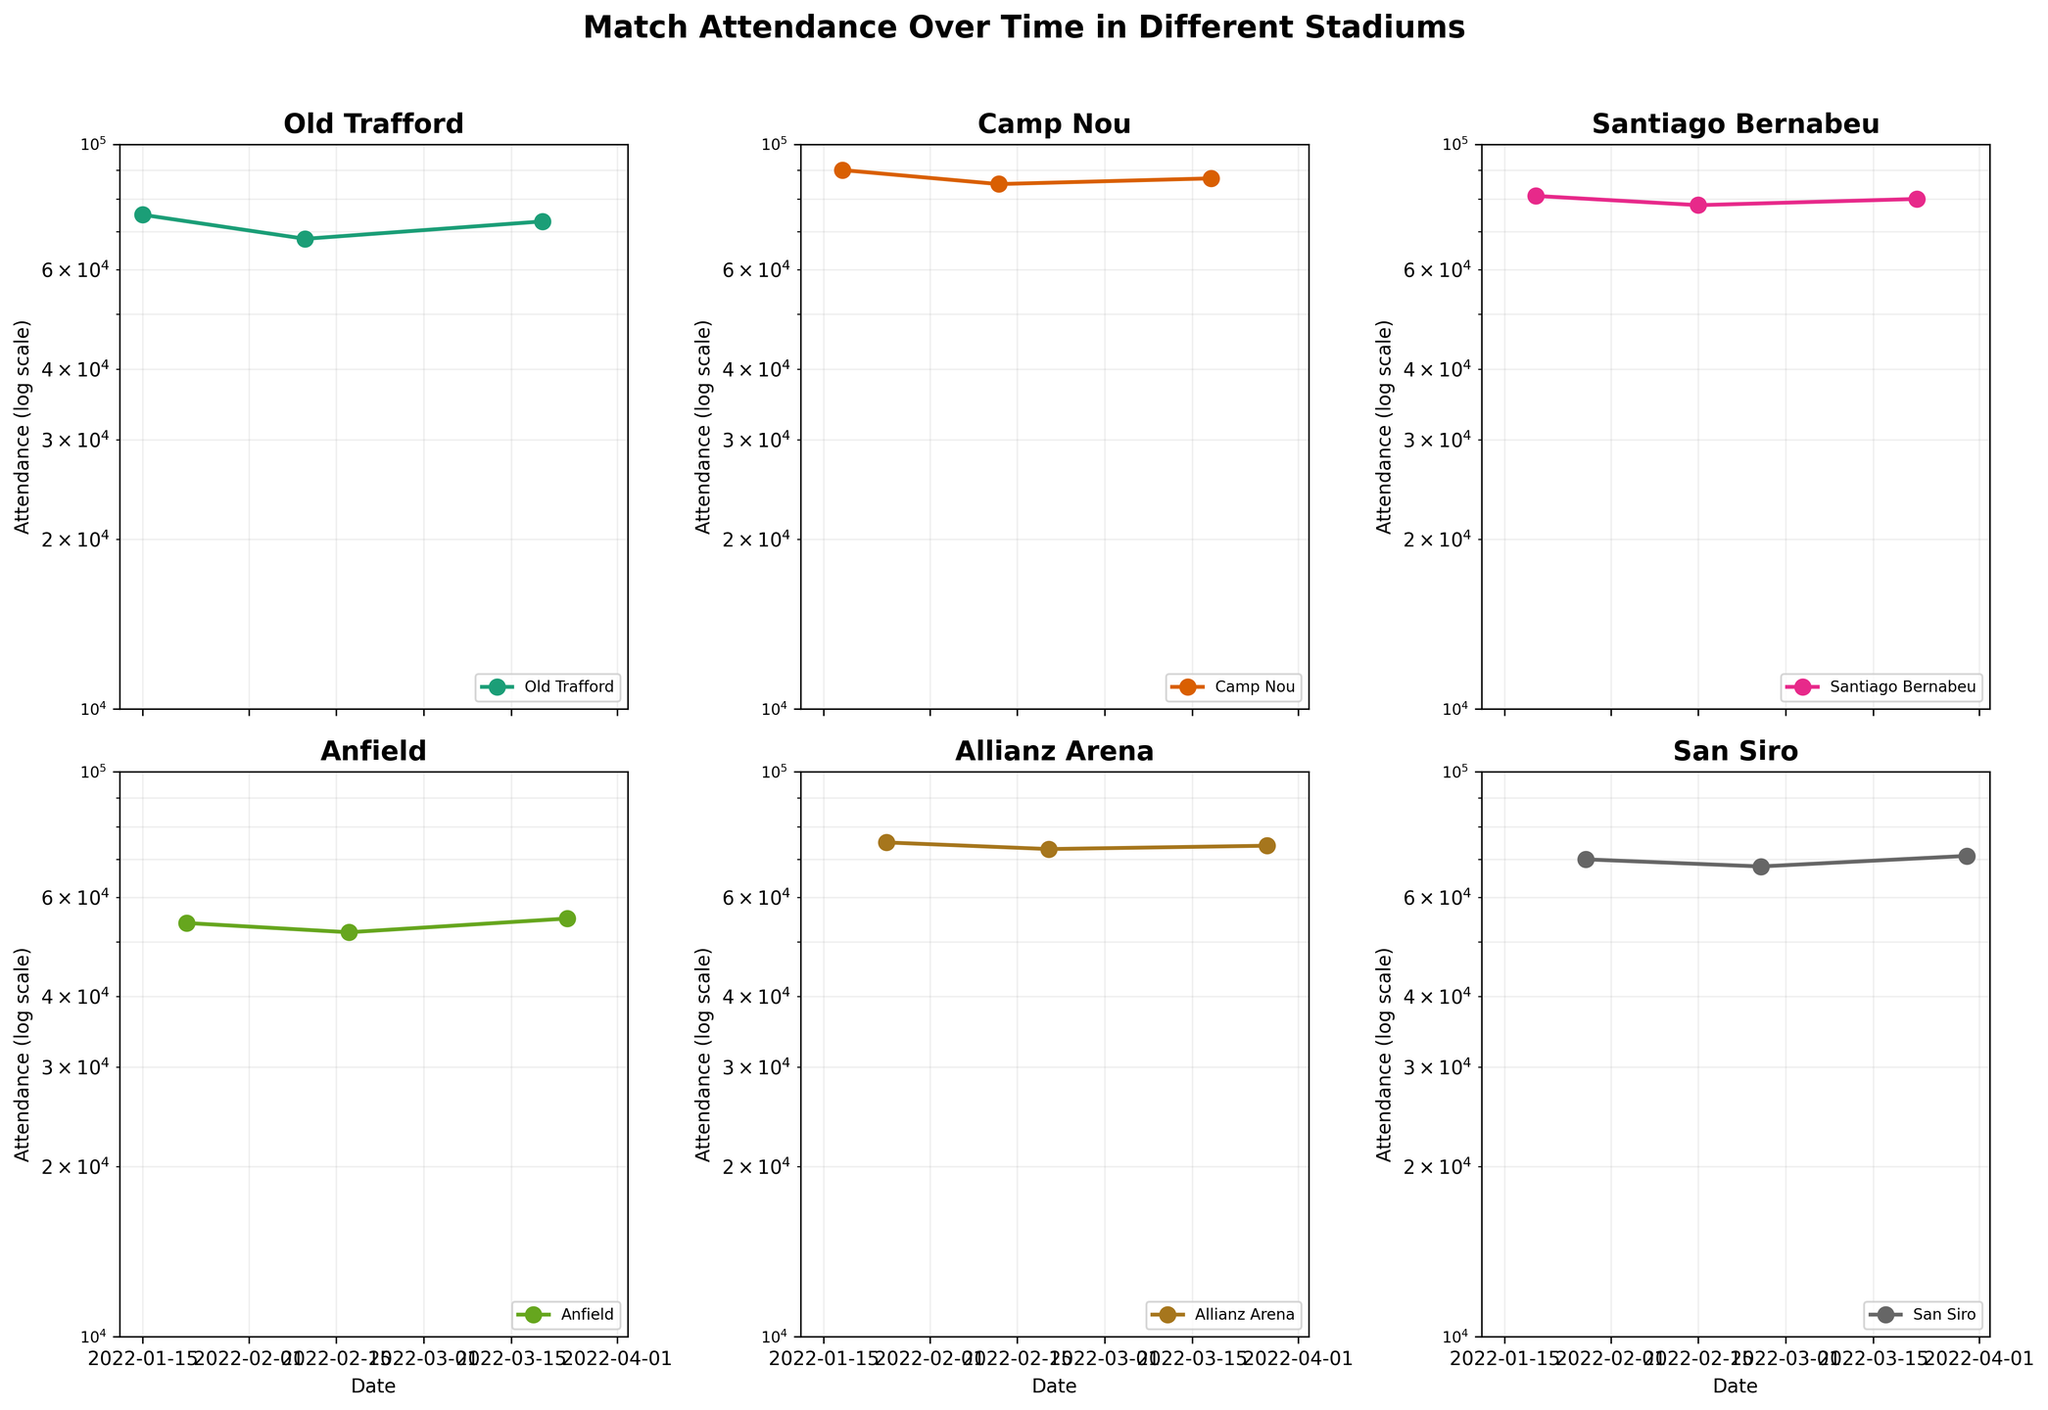what type of plot is used to display the data? The figure uses subplots with semi-logarithmic scales. On a semi-logarithmic plot, one axis (typically the y-axis) has a logarithmic scale, while the other axis (x-axis) has a linear scale. This type of plot is used here to display the attendance data for different stadiums over time.
Answer: Subplots with semi-logarithmic scales How many stadiums have their attendance data visualized? By counting the number of subplots in the figure, we can see attendance data visualized for five stadiums. Each subplot represents one stadium.
Answer: Five Which stadium had the highest match attendance in January 2022? To determine the highest match attendance in January 2022, we need to look at the attendance values on the semi-logarithmic plots for each stadium. The highest value in January is observed for Camp Nou.
Answer: Camp Nou Which stadium experienced the least variation in attendance over the period? The least variation can be visually assessed by comparing the range between the highest and lowest attendance values in each subplot. The stadium with the smallest range in attendance values over the period is Santiago Bernabeu, where the attendance fluctuates between 78000 and 81000.
Answer: Santiago Bernabeu How does the attendance trend at Anfield compare to that at Old Trafford? To compare the trends at Anfield and Old Trafford, observe the direction and steepness of the lines in the respective subplots. Anfield's attendance shows a relatively steady pattern with a slight increase towards March, while Old Trafford also shows a steady pattern but with a higher overall attendance.
Answer: Anfield increases slightly; Old Trafford steady with higher attendance On which dates were the attendance values recorded? The attendance values were recorded on three different dates: in January, February, and March of 2022. The specific dates are not indicated directly in the subplots but are 15th, 10th, and 20th for Old Trafford; 18th, 12th, and 18th for Camp Nou; 20th, 15th, and 22nd for Santiago Bernabeu; 22nd, 17th, and 24th for Anfield; 25th, 20th, and 27th for Allianz Arena; 28th, 25th, and 30th for San Siro.
Answer: January, February, March 2022 Which stadium had the highest average attendance? To find the stadium with the highest average attendance, we need to calculate the average attendance over the three data points for each stadium and compare them. The data are Camp Nou (90000, 85000, 87000). The average of these values will be greater than the rest.
Answer: Camp Nou What is the range of attendance values at Allianz Arena? The range is calculated by subtracting the smallest value from the largest value observed on the semi-logarithmic plot for Allianz Arena. From the data, the attendance values are 75000, 73000, and 74000.
Answer: 2000 Which stadium had a decrease in attendance from January to February but an increase from February to March? Observing the trends in the subplots, San Siro shows a decrease in attendance from January to February (70000 to 68000) and an increase from February to March (68000 to 71000).
Answer: San Siro 